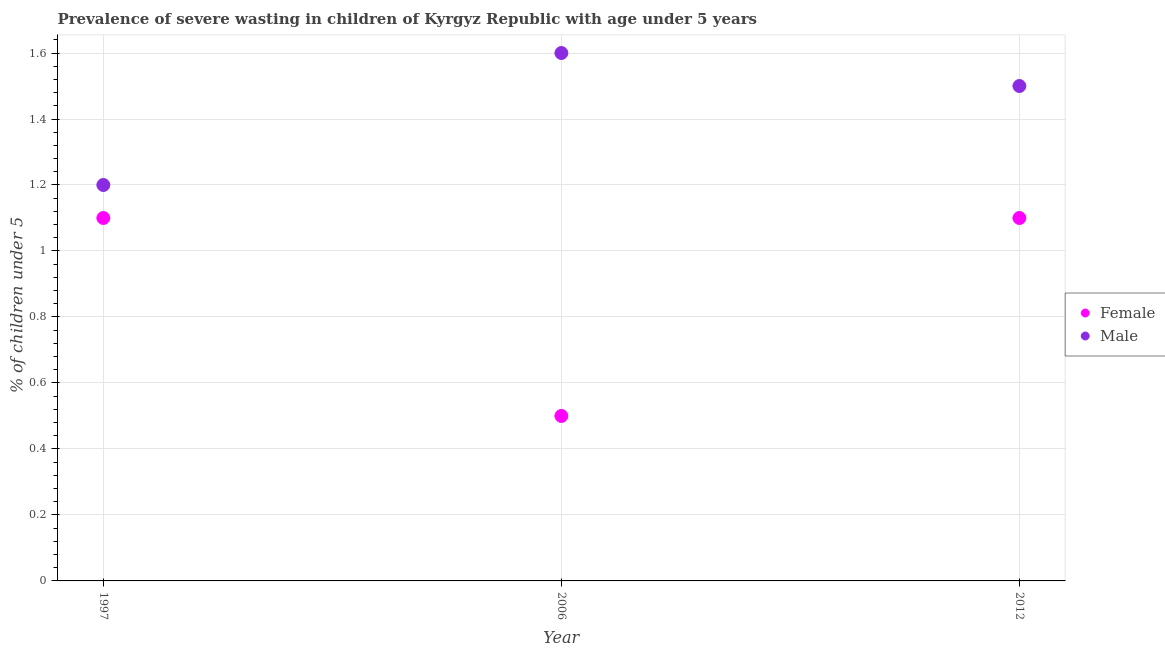How many different coloured dotlines are there?
Offer a terse response. 2. What is the percentage of undernourished male children in 2006?
Give a very brief answer. 1.6. Across all years, what is the maximum percentage of undernourished male children?
Make the answer very short. 1.6. Across all years, what is the minimum percentage of undernourished male children?
Give a very brief answer. 1.2. In which year was the percentage of undernourished female children minimum?
Keep it short and to the point. 2006. What is the total percentage of undernourished male children in the graph?
Provide a short and direct response. 4.3. What is the difference between the percentage of undernourished male children in 2006 and that in 2012?
Ensure brevity in your answer.  0.1. What is the difference between the percentage of undernourished male children in 1997 and the percentage of undernourished female children in 2006?
Ensure brevity in your answer.  0.7. What is the average percentage of undernourished male children per year?
Your response must be concise. 1.43. In the year 2012, what is the difference between the percentage of undernourished male children and percentage of undernourished female children?
Offer a terse response. 0.4. In how many years, is the percentage of undernourished female children greater than 0.28 %?
Give a very brief answer. 3. What is the ratio of the percentage of undernourished female children in 2006 to that in 2012?
Provide a succinct answer. 0.45. Is the difference between the percentage of undernourished male children in 1997 and 2006 greater than the difference between the percentage of undernourished female children in 1997 and 2006?
Provide a succinct answer. No. What is the difference between the highest and the second highest percentage of undernourished female children?
Give a very brief answer. 0. What is the difference between the highest and the lowest percentage of undernourished male children?
Provide a short and direct response. 0.4. In how many years, is the percentage of undernourished male children greater than the average percentage of undernourished male children taken over all years?
Your answer should be very brief. 2. Is the sum of the percentage of undernourished female children in 1997 and 2012 greater than the maximum percentage of undernourished male children across all years?
Keep it short and to the point. Yes. Is the percentage of undernourished male children strictly greater than the percentage of undernourished female children over the years?
Give a very brief answer. Yes. How many dotlines are there?
Keep it short and to the point. 2. What is the difference between two consecutive major ticks on the Y-axis?
Give a very brief answer. 0.2. Where does the legend appear in the graph?
Ensure brevity in your answer.  Center right. How are the legend labels stacked?
Your response must be concise. Vertical. What is the title of the graph?
Provide a short and direct response. Prevalence of severe wasting in children of Kyrgyz Republic with age under 5 years. Does "% of GNI" appear as one of the legend labels in the graph?
Provide a succinct answer. No. What is the label or title of the X-axis?
Offer a very short reply. Year. What is the label or title of the Y-axis?
Offer a very short reply.  % of children under 5. What is the  % of children under 5 in Female in 1997?
Your response must be concise. 1.1. What is the  % of children under 5 of Male in 1997?
Keep it short and to the point. 1.2. What is the  % of children under 5 in Male in 2006?
Ensure brevity in your answer.  1.6. What is the  % of children under 5 of Female in 2012?
Your answer should be very brief. 1.1. Across all years, what is the maximum  % of children under 5 of Female?
Make the answer very short. 1.1. Across all years, what is the maximum  % of children under 5 in Male?
Your answer should be very brief. 1.6. Across all years, what is the minimum  % of children under 5 in Male?
Offer a very short reply. 1.2. What is the difference between the  % of children under 5 of Male in 1997 and that in 2006?
Ensure brevity in your answer.  -0.4. What is the difference between the  % of children under 5 in Female in 1997 and that in 2012?
Provide a short and direct response. 0. What is the difference between the  % of children under 5 in Female in 1997 and the  % of children under 5 in Male in 2006?
Keep it short and to the point. -0.5. What is the difference between the  % of children under 5 in Female in 2006 and the  % of children under 5 in Male in 2012?
Provide a short and direct response. -1. What is the average  % of children under 5 of Female per year?
Provide a succinct answer. 0.9. What is the average  % of children under 5 in Male per year?
Provide a succinct answer. 1.43. What is the ratio of the  % of children under 5 of Male in 1997 to that in 2006?
Make the answer very short. 0.75. What is the ratio of the  % of children under 5 in Female in 1997 to that in 2012?
Your answer should be very brief. 1. What is the ratio of the  % of children under 5 in Female in 2006 to that in 2012?
Ensure brevity in your answer.  0.45. What is the ratio of the  % of children under 5 in Male in 2006 to that in 2012?
Ensure brevity in your answer.  1.07. What is the difference between the highest and the lowest  % of children under 5 of Female?
Give a very brief answer. 0.6. 